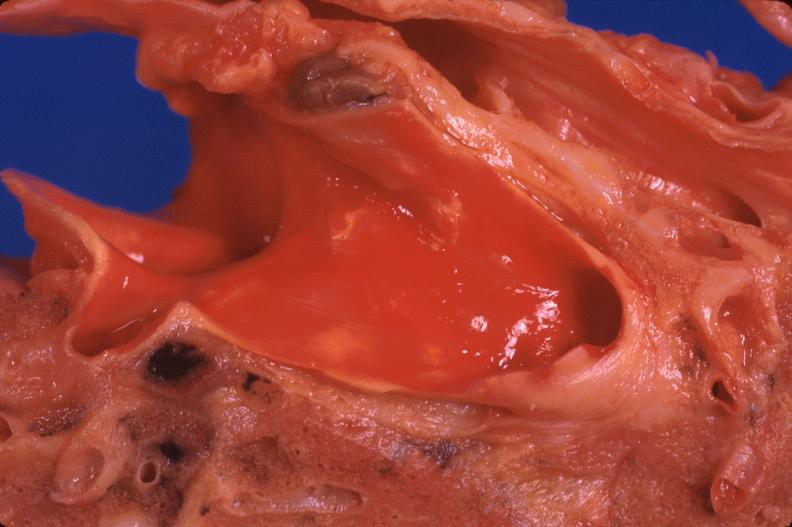does this image show lung, pulmonary fibrosis and atherosclerosis of pulmonary artery?
Answer the question using a single word or phrase. Yes 